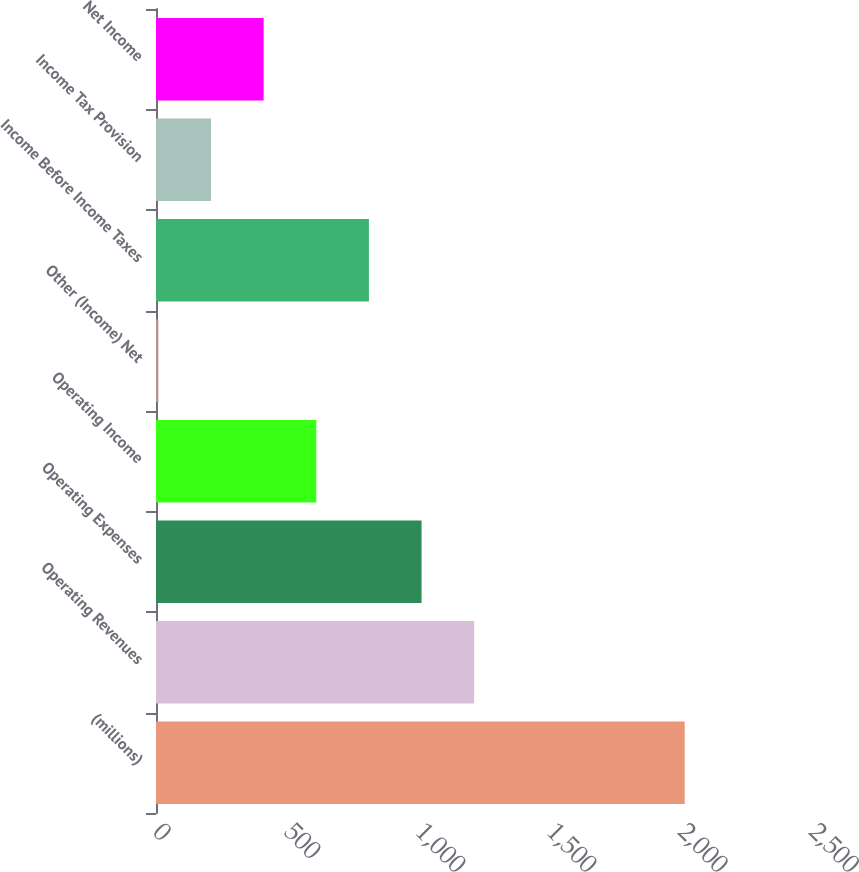<chart> <loc_0><loc_0><loc_500><loc_500><bar_chart><fcel>(millions)<fcel>Operating Revenues<fcel>Operating Expenses<fcel>Operating Income<fcel>Other (Income) Net<fcel>Income Before Income Taxes<fcel>Income Tax Provision<fcel>Net Income<nl><fcel>2015<fcel>1212.6<fcel>1012<fcel>610.8<fcel>9<fcel>811.4<fcel>209.6<fcel>410.2<nl></chart> 